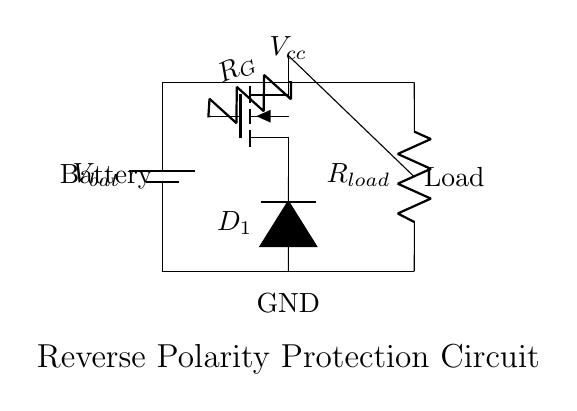What type of transistor is used in this circuit? The circuit uses an N-channel MOSFET, as indicated by the symbol labeled 'nfet'. This designation specifies the type of field-effect transistor used to control the load based on gate voltage.
Answer: N-channel MOSFET What is the purpose of the diode in this circuit? The diode, labeled 'D_1', prevents reverse current from flowing through the circuit when the battery is connected with reverse polarity. It blocks current in the reverse direction, protecting the load and components.
Answer: Reverse current protection What is the role of the resistor labeled R_G? The resistor R_G serves as a gate resistor for the N-channel MOSFET, controlling the gate voltage and ensuring that the MOSFET turns on or off appropriately in response to the voltage from the battery.
Answer: Gate control What happens if the battery is connected with reverse polarity? If the battery is connected in reverse, the diode will become reverse-biased and block any current from flowing, preventing damage to the load and the circuit's components.
Answer: No current flows How many connections are made to the load in this circuit? The load is connected to two points in the circuit: one from the drain of the MOSFET and the other from the terminal of the battery. This configuration allows it to receive power only when the battery is connected correctly.
Answer: Two connections What voltage can be expected across R_load during normal operation? During normal operation, when the battery is connected correctly, the voltage across R_load will be equal to the battery voltage V_bat minus any voltage drop across the MOSFET, typically approximated as near the battery voltage in ideal conditions.
Answer: V_bat 